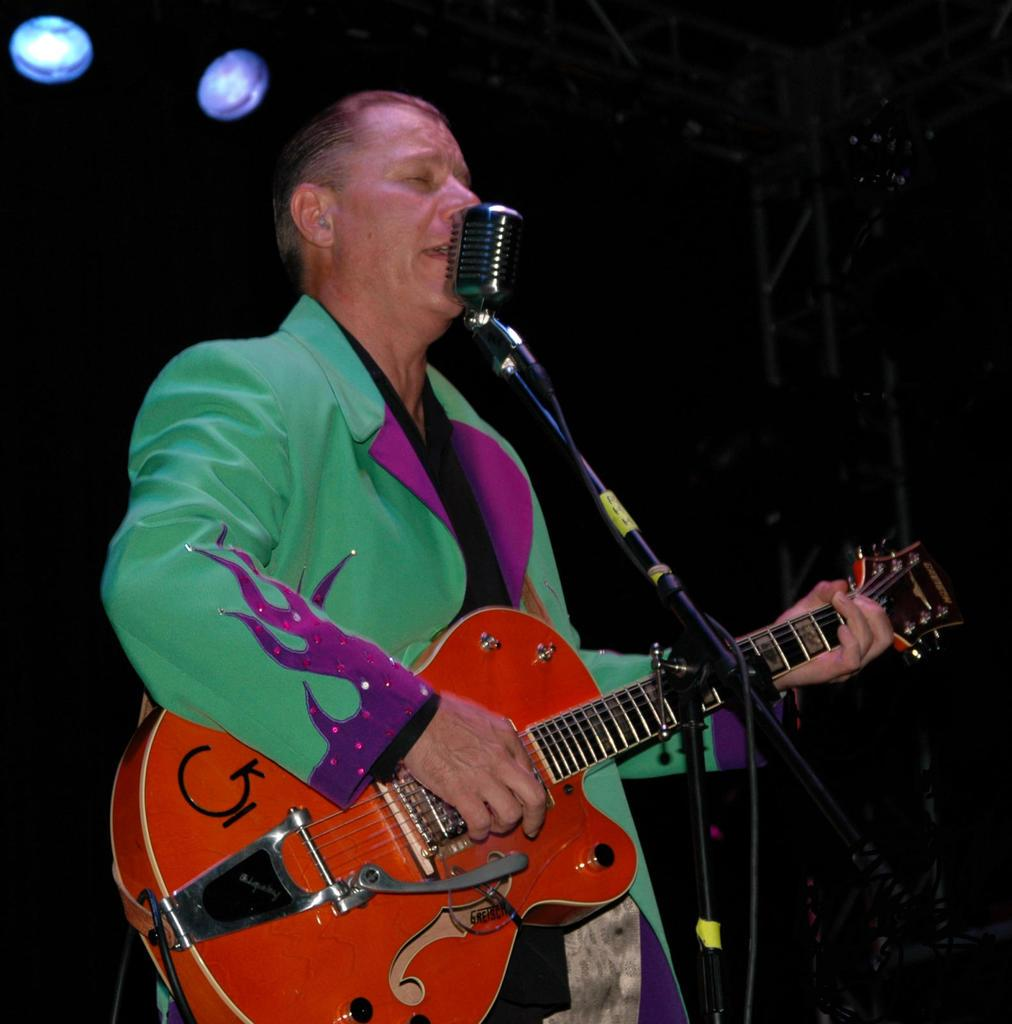What is the man in the image doing? The man is playing a guitar and singing. How is the man amplifying his voice in the image? The man is using a microphone. What type of celery is the man holding in the image? There is no celery present in the image; the man is playing a guitar and singing. 